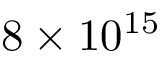Convert formula to latex. <formula><loc_0><loc_0><loc_500><loc_500>8 \times 1 0 ^ { 1 5 }</formula> 